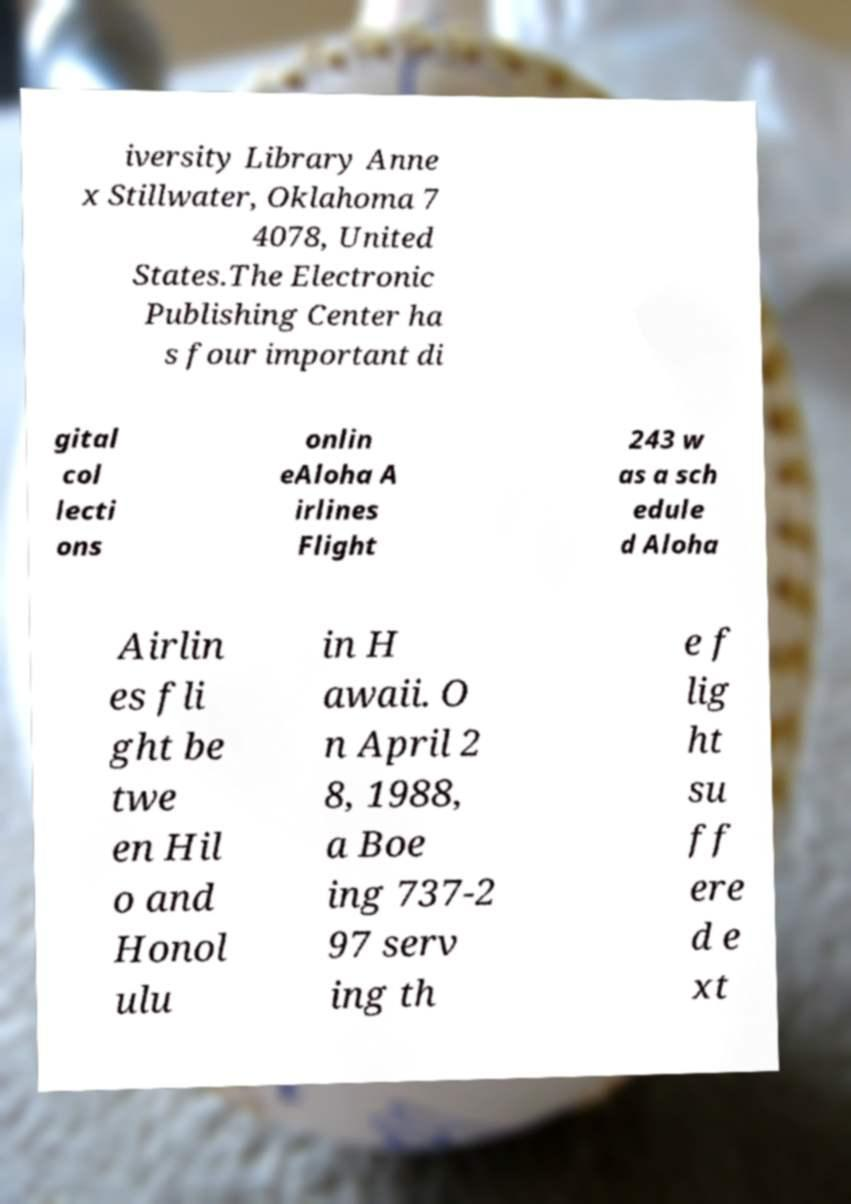Could you assist in decoding the text presented in this image and type it out clearly? iversity Library Anne x Stillwater, Oklahoma 7 4078, United States.The Electronic Publishing Center ha s four important di gital col lecti ons onlin eAloha A irlines Flight 243 w as a sch edule d Aloha Airlin es fli ght be twe en Hil o and Honol ulu in H awaii. O n April 2 8, 1988, a Boe ing 737-2 97 serv ing th e f lig ht su ff ere d e xt 